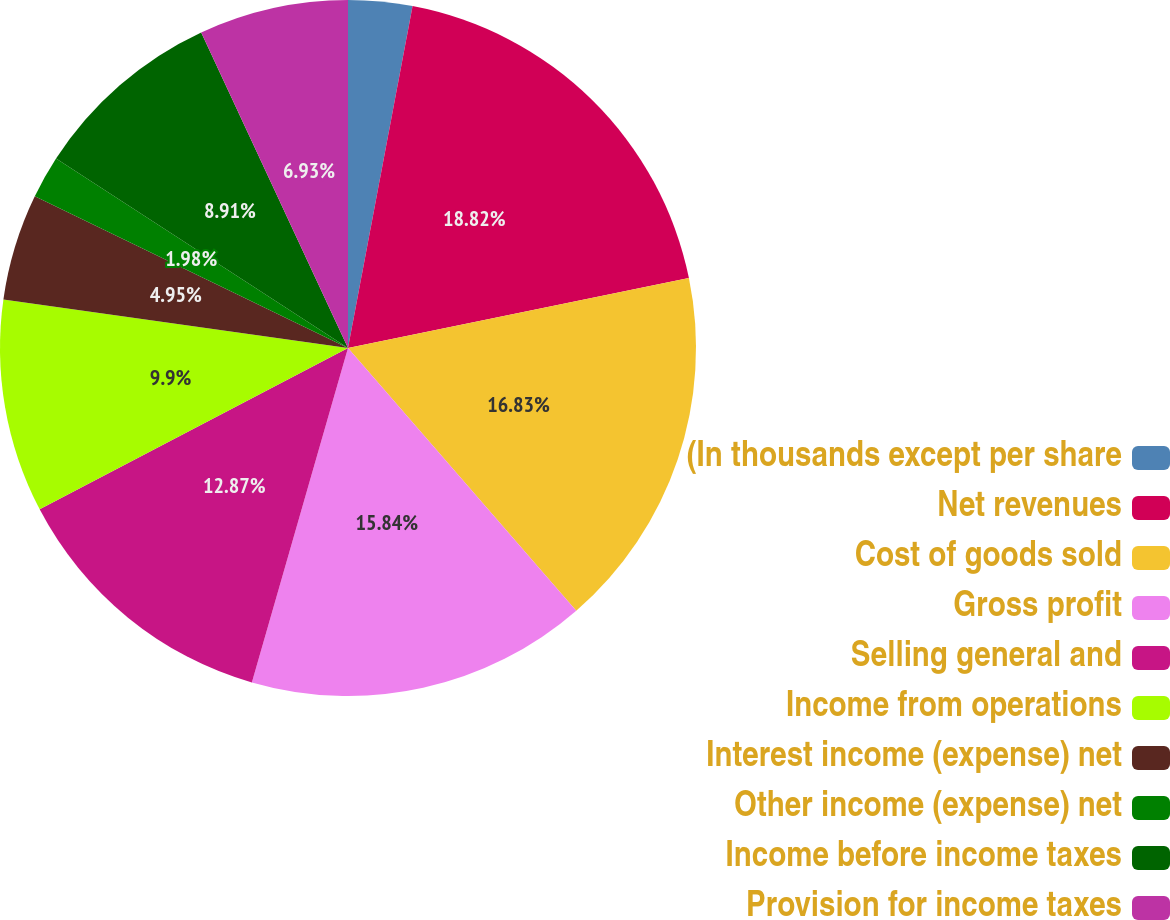Convert chart. <chart><loc_0><loc_0><loc_500><loc_500><pie_chart><fcel>(In thousands except per share<fcel>Net revenues<fcel>Cost of goods sold<fcel>Gross profit<fcel>Selling general and<fcel>Income from operations<fcel>Interest income (expense) net<fcel>Other income (expense) net<fcel>Income before income taxes<fcel>Provision for income taxes<nl><fcel>2.97%<fcel>18.81%<fcel>16.83%<fcel>15.84%<fcel>12.87%<fcel>9.9%<fcel>4.95%<fcel>1.98%<fcel>8.91%<fcel>6.93%<nl></chart> 